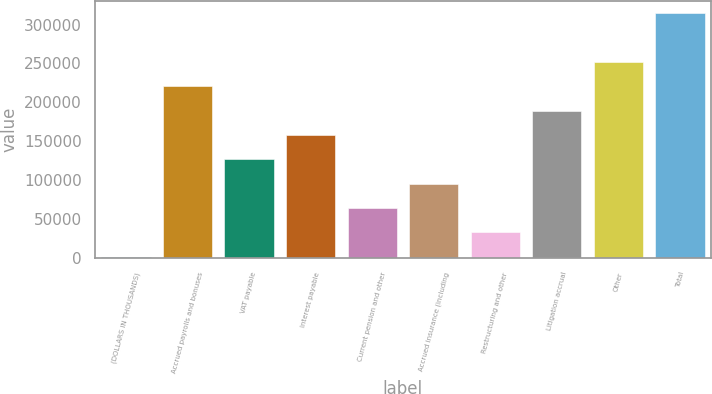Convert chart. <chart><loc_0><loc_0><loc_500><loc_500><bar_chart><fcel>(DOLLARS IN THOUSANDS)<fcel>Accrued payrolls and bonuses<fcel>VAT payable<fcel>Interest payable<fcel>Current pension and other<fcel>Accrued insurance (including<fcel>Restructuring and other<fcel>Litigation accrual<fcel>Other<fcel>Total<nl><fcel>2016<fcel>220606<fcel>126925<fcel>158152<fcel>64470.4<fcel>95697.6<fcel>33243.2<fcel>189379<fcel>251834<fcel>314288<nl></chart> 